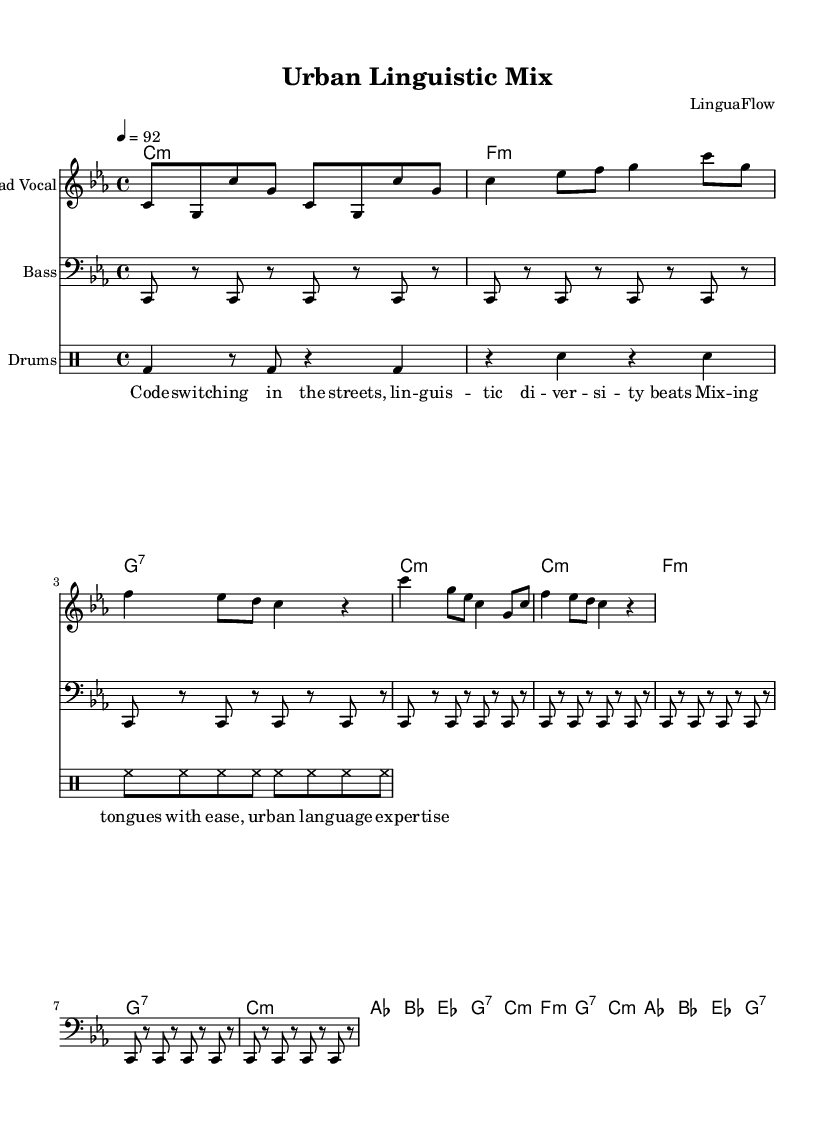What is the key signature of this music? The key signature is C minor, which is indicated at the beginning of the score with three flats.
Answer: C minor What is the time signature of this music? The time signature is 4/4, shown at the beginning of the music, meaning there are four beats in a measure.
Answer: 4/4 What is the tempo marking for this piece? The tempo marking is 92 beats per minute, which is indicated at the start of the score.
Answer: 92 How many measures are there in the verse section? The verse section contains 4 measures, as shown by the grouping of notes following the introductory measures.
Answer: 4 What musical form is primarily used in this rap song? The rap song primarily uses a verse-chorus form, alternating between the verses and the chorus sections.
Answer: Verse-chorus What is the main theme explored in the lyrics? The main theme is linguistic diversity and code-switching in urban contexts, as indicated by the lyrics discussing code-switching and urban language expertise.
Answer: Linguistic diversity What role do the drums serve in this rap music? The drums provide a rhythmic foundation and enhance the beat, which is essential for the dynamic flow of rap music.
Answer: Rhythmic foundation 